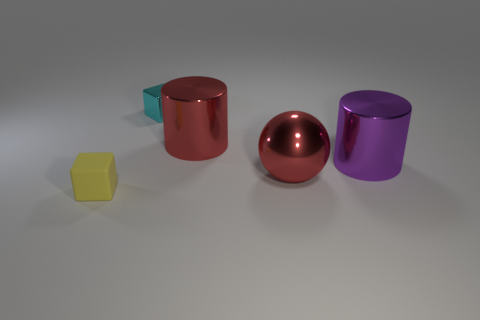Add 3 blue metal balls. How many objects exist? 8 Subtract all cyan cubes. How many cubes are left? 1 Subtract all cylinders. How many objects are left? 3 Subtract 1 balls. How many balls are left? 0 Subtract all red cylinders. Subtract all red blocks. How many cylinders are left? 1 Subtract all yellow spheres. How many yellow cubes are left? 1 Subtract all big blue metallic cylinders. Subtract all cyan shiny cubes. How many objects are left? 4 Add 5 yellow cubes. How many yellow cubes are left? 6 Add 3 red shiny balls. How many red shiny balls exist? 4 Subtract 0 blue cylinders. How many objects are left? 5 